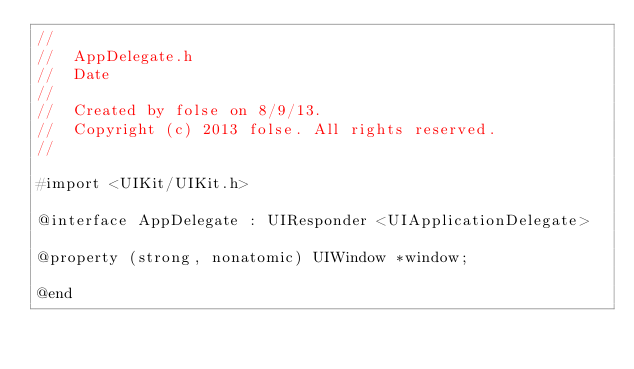<code> <loc_0><loc_0><loc_500><loc_500><_C_>//
//  AppDelegate.h
//  Date
//
//  Created by folse on 8/9/13.
//  Copyright (c) 2013 folse. All rights reserved.
//

#import <UIKit/UIKit.h>

@interface AppDelegate : UIResponder <UIApplicationDelegate>

@property (strong, nonatomic) UIWindow *window;

@end
</code> 